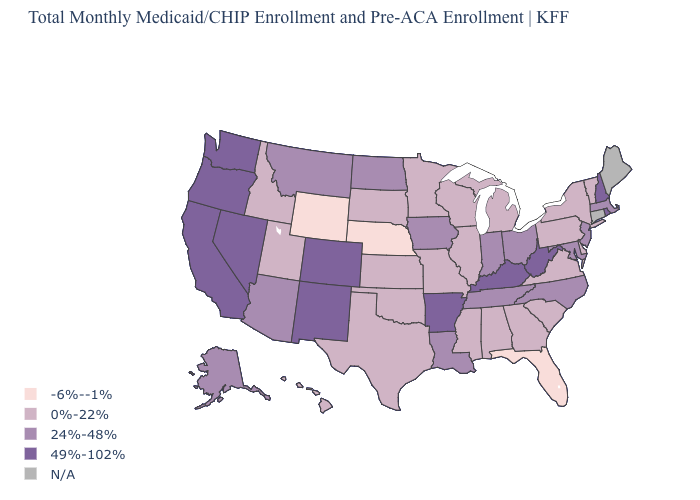Which states have the lowest value in the Northeast?
Write a very short answer. New York, Pennsylvania, Vermont. Name the states that have a value in the range 0%-22%?
Short answer required. Alabama, Delaware, Georgia, Hawaii, Idaho, Illinois, Kansas, Michigan, Minnesota, Mississippi, Missouri, New York, Oklahoma, Pennsylvania, South Carolina, South Dakota, Texas, Utah, Vermont, Virginia, Wisconsin. What is the value of Hawaii?
Answer briefly. 0%-22%. Which states have the lowest value in the USA?
Answer briefly. Florida, Nebraska, Wyoming. Does the map have missing data?
Keep it brief. Yes. Does North Dakota have the lowest value in the MidWest?
Write a very short answer. No. Does the first symbol in the legend represent the smallest category?
Answer briefly. Yes. How many symbols are there in the legend?
Quick response, please. 5. What is the value of Hawaii?
Write a very short answer. 0%-22%. Among the states that border Wisconsin , which have the lowest value?
Be succinct. Illinois, Michigan, Minnesota. What is the lowest value in states that border West Virginia?
Give a very brief answer. 0%-22%. What is the highest value in states that border Connecticut?
Keep it brief. 49%-102%. Which states hav the highest value in the South?
Write a very short answer. Arkansas, Kentucky, West Virginia. What is the value of Massachusetts?
Short answer required. 24%-48%. What is the value of Tennessee?
Be succinct. 24%-48%. 